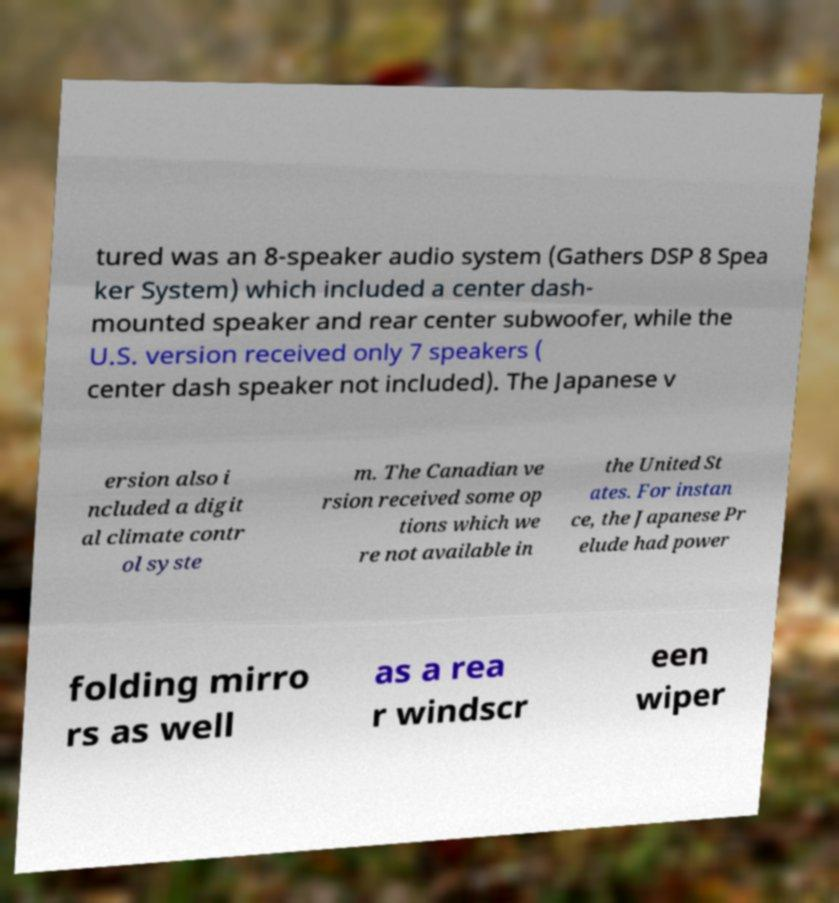For documentation purposes, I need the text within this image transcribed. Could you provide that? tured was an 8-speaker audio system (Gathers DSP 8 Spea ker System) which included a center dash- mounted speaker and rear center subwoofer, while the U.S. version received only 7 speakers ( center dash speaker not included). The Japanese v ersion also i ncluded a digit al climate contr ol syste m. The Canadian ve rsion received some op tions which we re not available in the United St ates. For instan ce, the Japanese Pr elude had power folding mirro rs as well as a rea r windscr een wiper 